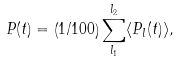<formula> <loc_0><loc_0><loc_500><loc_500>P ( t ) = \left ( 1 / 1 0 0 \right ) \sum _ { l _ { 1 } } ^ { l _ { 2 } } \langle P _ { l } ( t ) \rangle ,</formula> 